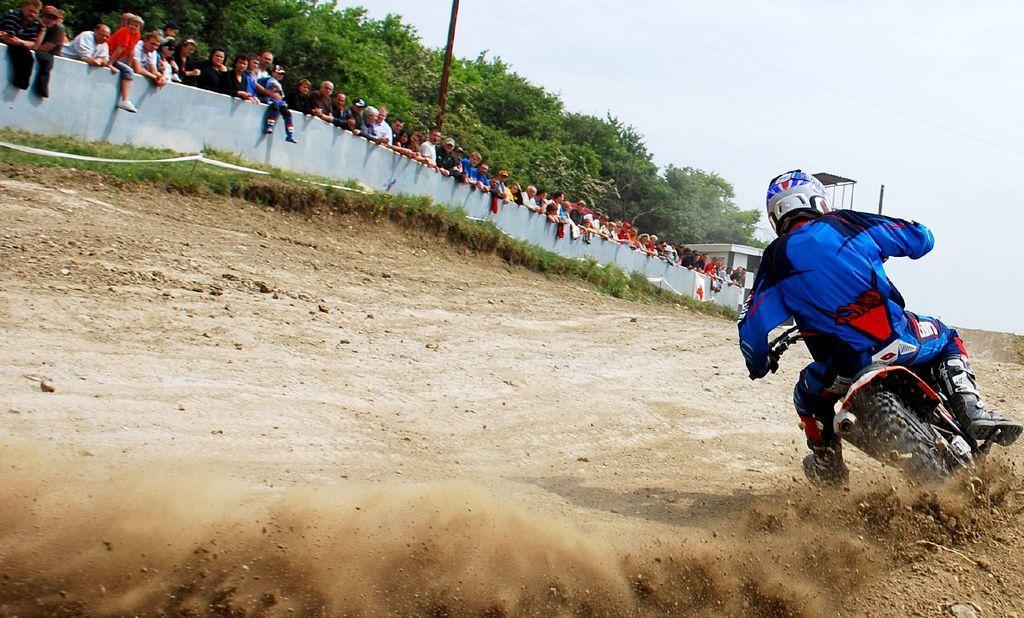Can you describe this image briefly? In this image we can see a person wearing helmet. He is riding on a motorcycle. On the ground there is grass. Near to the wall there are many people standing. In the back there are trees. And there is sky. 